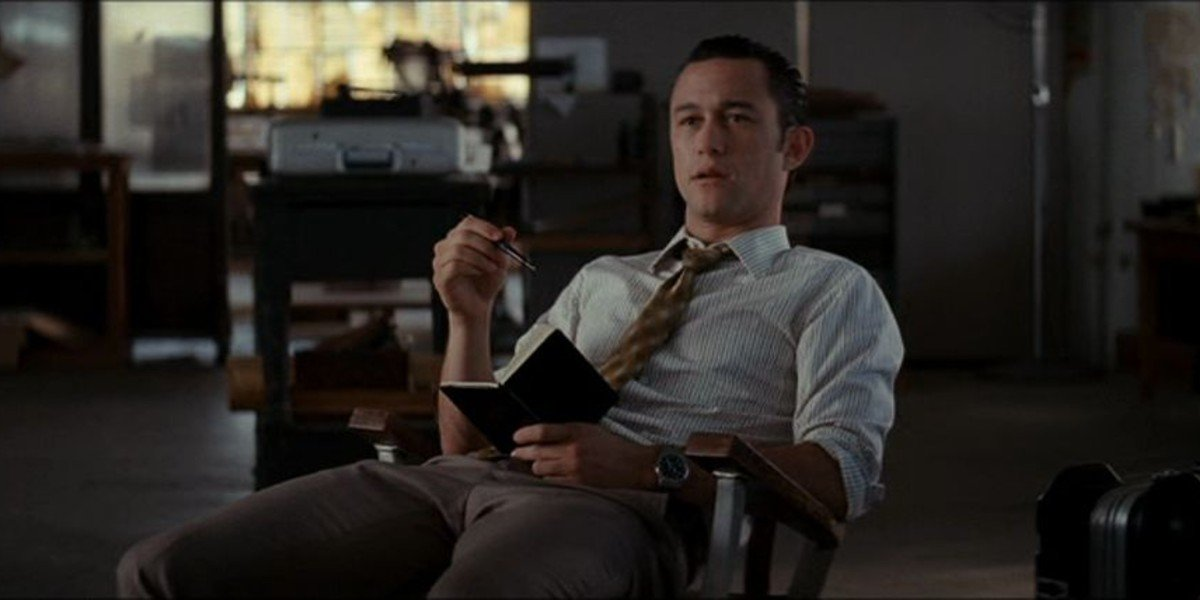What would happen if a sudden phone call interrupted him right now? If a sudden phone call interrupted him, he might startle slightly, snapping out of his deep thoughts. He would then sit up straight, compose himself quickly, and check the caller ID. Depending on the importance of the call, his demeanor could shift from thoughtful to alert, ready to discuss urgent matters with a colleague or client. His poised concentration suggests he is capable of swiftly transitioning between reflective and responsive states. 